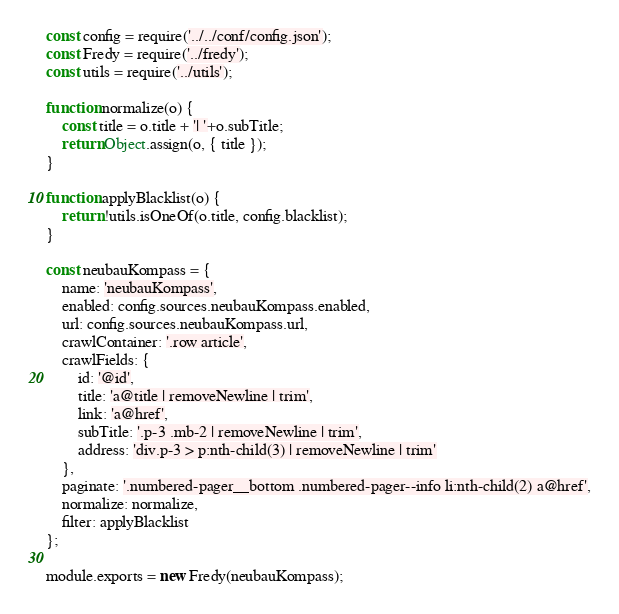<code> <loc_0><loc_0><loc_500><loc_500><_JavaScript_>const config = require('../../conf/config.json');
const Fredy = require('../fredy');
const utils = require('../utils');

function normalize(o) {
    const title = o.title + '| '+o.subTitle;
    return Object.assign(o, { title });
}

function applyBlacklist(o) {
    return !utils.isOneOf(o.title, config.blacklist);
}

const neubauKompass = {
    name: 'neubauKompass',
    enabled: config.sources.neubauKompass.enabled,
    url: config.sources.neubauKompass.url,
    crawlContainer: '.row article',
    crawlFields: {
        id: '@id',
        title: 'a@title | removeNewline | trim',
        link: 'a@href',
        subTitle: '.p-3 .mb-2 | removeNewline | trim',
        address: 'div.p-3 > p:nth-child(3) | removeNewline | trim'
    },
    paginate: '.numbered-pager__bottom .numbered-pager--info li:nth-child(2) a@href',
    normalize: normalize,
    filter: applyBlacklist
};

module.exports = new Fredy(neubauKompass);
</code> 